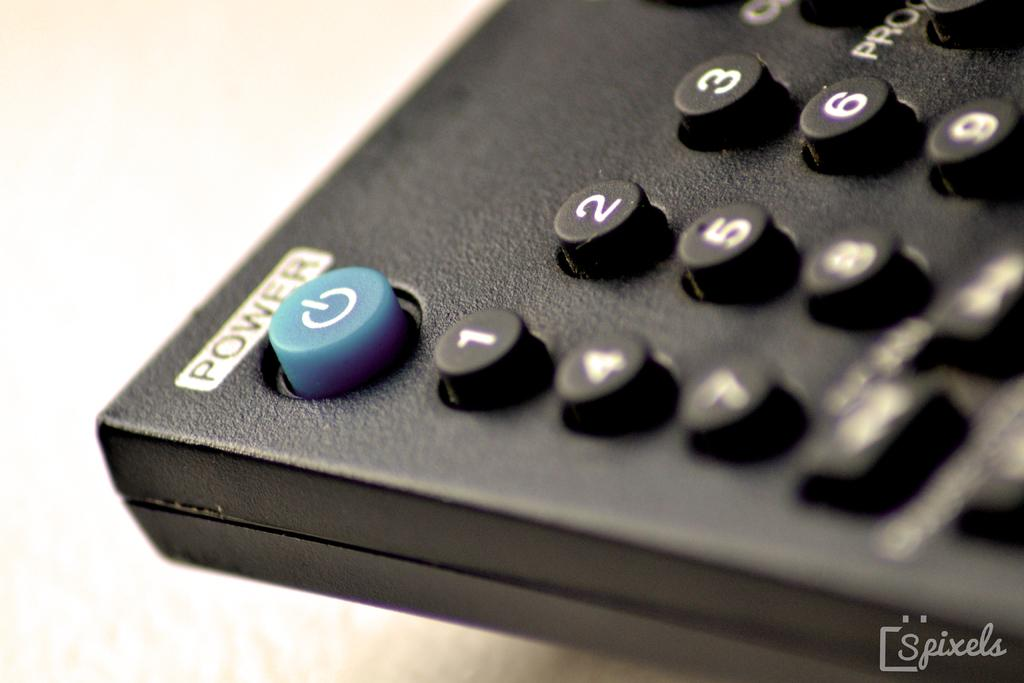What object is present in the image that is used for controlling electronic devices? There is a remote in the image. What function does the remote have? The remote has a power button and number buttons. Is there any visible marking in the image? Yes, there is a watermark in the bottom right corner of the image. How many deer can be seen inside the cave in the image? There are no deer or caves present in the image; it features a remote with a power button and number buttons. What degree of difficulty is required to complete the task shown in the image? The image does not depict a task or any level of difficulty; it shows a remote with buttons. 